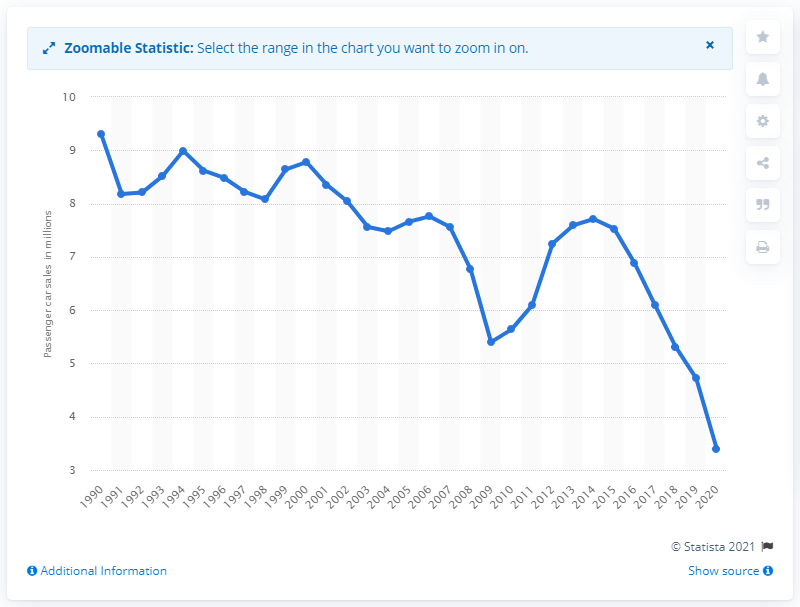Highlight a few significant elements in this photo. In the year 2020, U.S. auto shoppers purchased approximately 3.4 million vehicles. In 2020, U.S. auto shoppers purchased a total of 3.4 autos. 